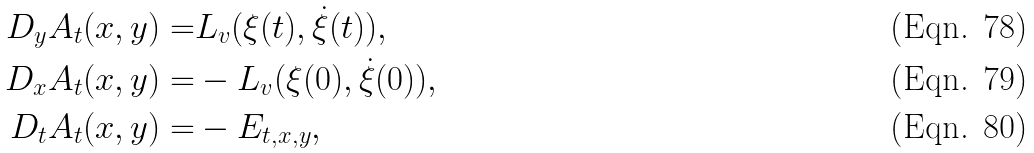Convert formula to latex. <formula><loc_0><loc_0><loc_500><loc_500>D _ { y } A _ { t } ( x , y ) = & L _ { v } ( \xi ( t ) , \dot { \xi } ( t ) ) , \\ D _ { x } A _ { t } ( x , y ) = & - L _ { v } ( \xi ( 0 ) , \dot { \xi } ( 0 ) ) , \\ D _ { t } A _ { t } ( x , y ) = & - E _ { t , x , y } ,</formula> 